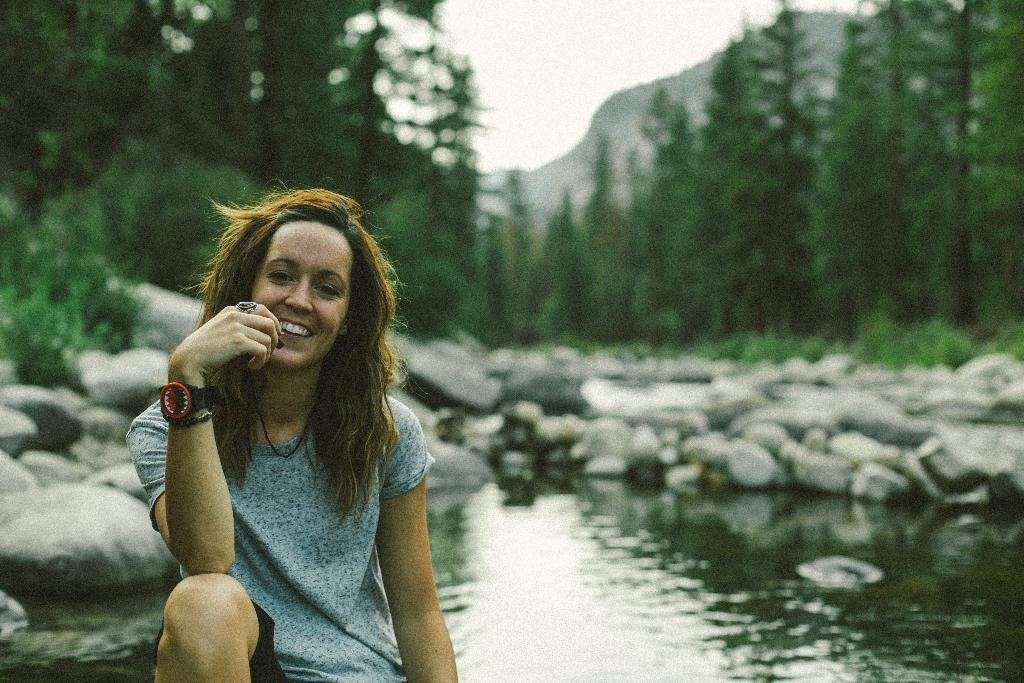Who is present in the image? There is a woman in the image. Where is the woman sitting in relation to the image? The woman is sitting on the left side. What is the woman's facial expression in the image? The woman is smiling. What can be seen behind the woman in the image? There is a small pond and rocks in the background of the image. What other natural elements are visible in the background of the image? There are trees and the sky visible in the background of the image. What type of feast is being prepared in the image? There is no indication of a feast or any food preparation in the image. Can you see a zebra in the image? No, there is no zebra present in the image. 